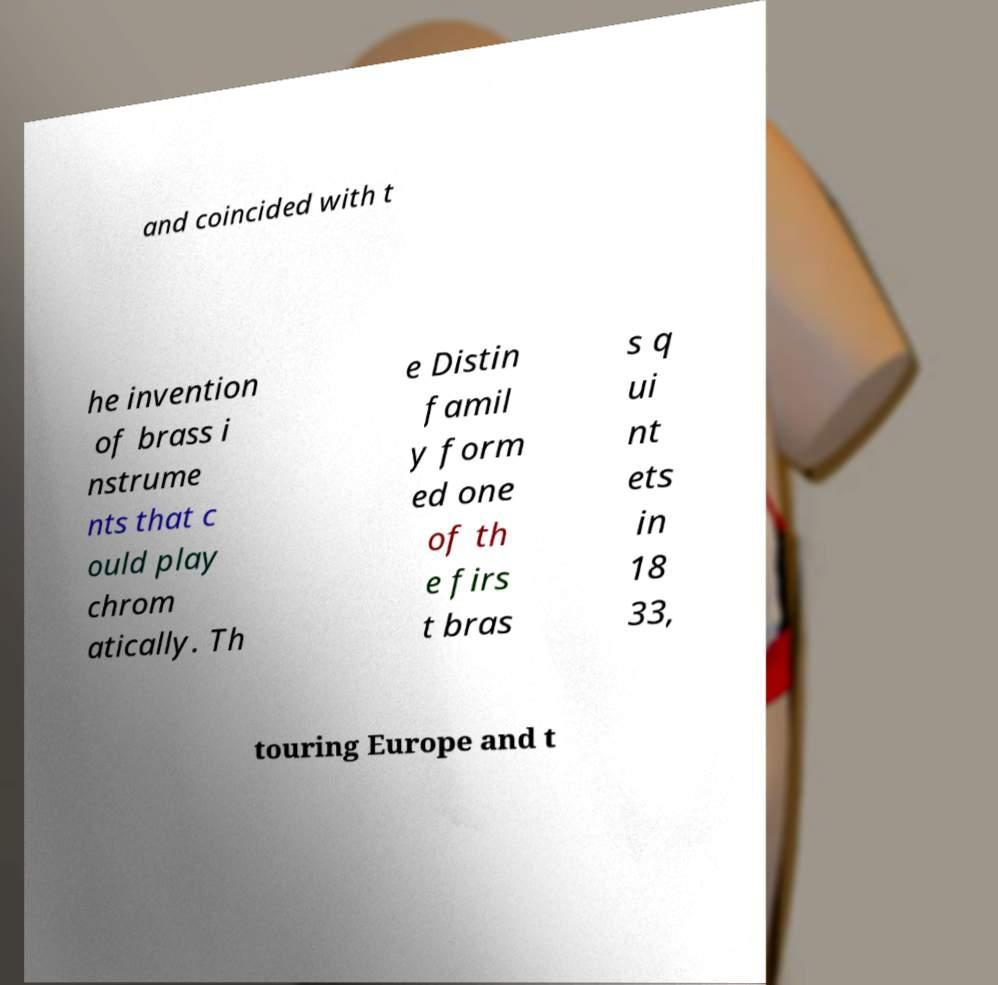What messages or text are displayed in this image? I need them in a readable, typed format. and coincided with t he invention of brass i nstrume nts that c ould play chrom atically. Th e Distin famil y form ed one of th e firs t bras s q ui nt ets in 18 33, touring Europe and t 